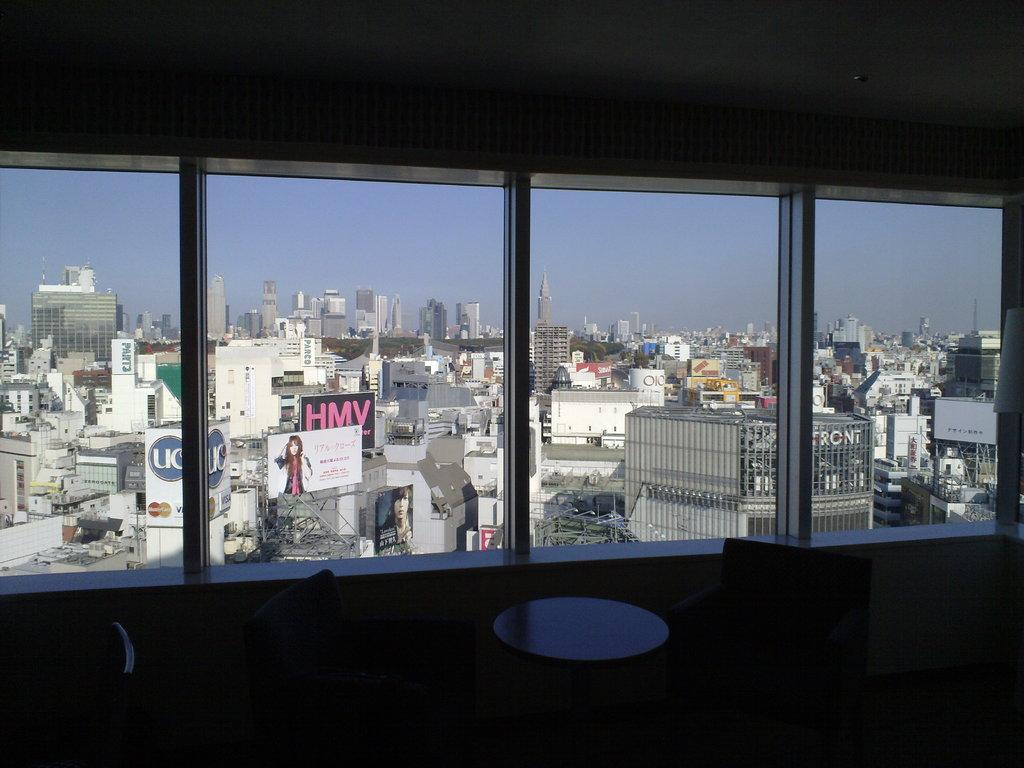What type of furniture is present in the image? There is a table in the image. Are there any seats near the table? Yes, there are chairs around the table. What can be seen beside the table? There is a glass window beside the table. What is visible in the background of the image? There are buildings in the background of the image. Where is the toy cemetery located in the image? There is no toy cemetery present in the image. 